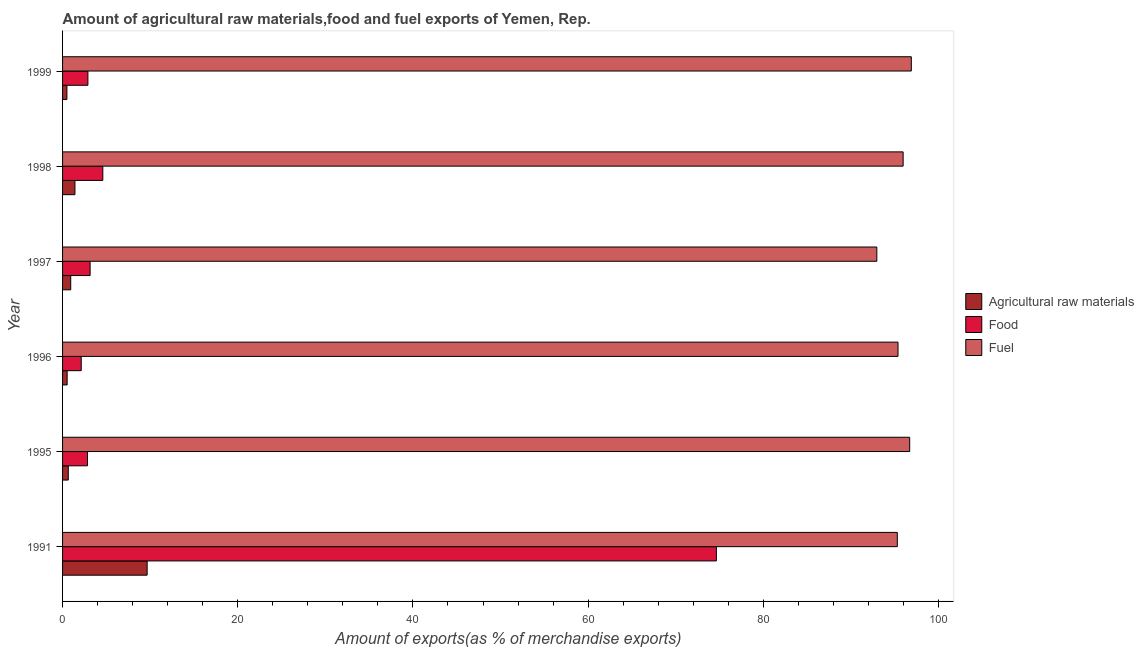How many different coloured bars are there?
Make the answer very short. 3. Are the number of bars per tick equal to the number of legend labels?
Your answer should be very brief. Yes. Are the number of bars on each tick of the Y-axis equal?
Make the answer very short. Yes. What is the percentage of fuel exports in 1991?
Make the answer very short. 95.3. Across all years, what is the maximum percentage of fuel exports?
Give a very brief answer. 96.9. Across all years, what is the minimum percentage of fuel exports?
Your answer should be very brief. 92.96. In which year was the percentage of food exports minimum?
Keep it short and to the point. 1996. What is the total percentage of raw materials exports in the graph?
Your answer should be compact. 13.67. What is the difference between the percentage of raw materials exports in 1998 and that in 1999?
Give a very brief answer. 0.92. What is the difference between the percentage of food exports in 1995 and the percentage of fuel exports in 1996?
Offer a very short reply. -92.53. What is the average percentage of fuel exports per year?
Offer a very short reply. 95.54. In the year 1995, what is the difference between the percentage of food exports and percentage of raw materials exports?
Your response must be concise. 2.19. What is the ratio of the percentage of fuel exports in 1991 to that in 1999?
Offer a very short reply. 0.98. Is the percentage of fuel exports in 1991 less than that in 1995?
Offer a terse response. Yes. Is the difference between the percentage of fuel exports in 1996 and 1998 greater than the difference between the percentage of raw materials exports in 1996 and 1998?
Offer a very short reply. Yes. What is the difference between the highest and the second highest percentage of raw materials exports?
Keep it short and to the point. 8.24. What is the difference between the highest and the lowest percentage of fuel exports?
Offer a terse response. 3.94. In how many years, is the percentage of food exports greater than the average percentage of food exports taken over all years?
Provide a short and direct response. 1. Is the sum of the percentage of food exports in 1991 and 1995 greater than the maximum percentage of raw materials exports across all years?
Offer a very short reply. Yes. What does the 1st bar from the top in 1995 represents?
Give a very brief answer. Fuel. What does the 1st bar from the bottom in 1998 represents?
Your answer should be compact. Agricultural raw materials. Are all the bars in the graph horizontal?
Provide a succinct answer. Yes. What is the difference between two consecutive major ticks on the X-axis?
Ensure brevity in your answer.  20. Are the values on the major ticks of X-axis written in scientific E-notation?
Your answer should be compact. No. Does the graph contain any zero values?
Give a very brief answer. No. Does the graph contain grids?
Your answer should be compact. No. Where does the legend appear in the graph?
Ensure brevity in your answer.  Center right. How are the legend labels stacked?
Make the answer very short. Vertical. What is the title of the graph?
Offer a very short reply. Amount of agricultural raw materials,food and fuel exports of Yemen, Rep. Does "Transport equipments" appear as one of the legend labels in the graph?
Offer a terse response. No. What is the label or title of the X-axis?
Offer a terse response. Amount of exports(as % of merchandise exports). What is the label or title of the Y-axis?
Your answer should be very brief. Year. What is the Amount of exports(as % of merchandise exports) in Agricultural raw materials in 1991?
Provide a succinct answer. 9.65. What is the Amount of exports(as % of merchandise exports) in Food in 1991?
Offer a very short reply. 74.64. What is the Amount of exports(as % of merchandise exports) in Fuel in 1991?
Provide a succinct answer. 95.3. What is the Amount of exports(as % of merchandise exports) of Agricultural raw materials in 1995?
Your response must be concise. 0.65. What is the Amount of exports(as % of merchandise exports) of Food in 1995?
Provide a short and direct response. 2.85. What is the Amount of exports(as % of merchandise exports) in Fuel in 1995?
Provide a succinct answer. 96.71. What is the Amount of exports(as % of merchandise exports) in Agricultural raw materials in 1996?
Your response must be concise. 0.52. What is the Amount of exports(as % of merchandise exports) in Food in 1996?
Offer a very short reply. 2.13. What is the Amount of exports(as % of merchandise exports) of Fuel in 1996?
Offer a terse response. 95.38. What is the Amount of exports(as % of merchandise exports) in Agricultural raw materials in 1997?
Give a very brief answer. 0.93. What is the Amount of exports(as % of merchandise exports) of Food in 1997?
Ensure brevity in your answer.  3.14. What is the Amount of exports(as % of merchandise exports) in Fuel in 1997?
Your answer should be compact. 92.96. What is the Amount of exports(as % of merchandise exports) of Agricultural raw materials in 1998?
Offer a very short reply. 1.41. What is the Amount of exports(as % of merchandise exports) in Food in 1998?
Make the answer very short. 4.59. What is the Amount of exports(as % of merchandise exports) of Fuel in 1998?
Offer a terse response. 95.96. What is the Amount of exports(as % of merchandise exports) in Agricultural raw materials in 1999?
Your response must be concise. 0.5. What is the Amount of exports(as % of merchandise exports) in Food in 1999?
Your answer should be very brief. 2.89. What is the Amount of exports(as % of merchandise exports) of Fuel in 1999?
Give a very brief answer. 96.9. Across all years, what is the maximum Amount of exports(as % of merchandise exports) in Agricultural raw materials?
Keep it short and to the point. 9.65. Across all years, what is the maximum Amount of exports(as % of merchandise exports) in Food?
Offer a terse response. 74.64. Across all years, what is the maximum Amount of exports(as % of merchandise exports) of Fuel?
Your response must be concise. 96.9. Across all years, what is the minimum Amount of exports(as % of merchandise exports) of Agricultural raw materials?
Provide a succinct answer. 0.5. Across all years, what is the minimum Amount of exports(as % of merchandise exports) in Food?
Offer a terse response. 2.13. Across all years, what is the minimum Amount of exports(as % of merchandise exports) of Fuel?
Ensure brevity in your answer.  92.96. What is the total Amount of exports(as % of merchandise exports) of Agricultural raw materials in the graph?
Offer a terse response. 13.67. What is the total Amount of exports(as % of merchandise exports) of Food in the graph?
Your response must be concise. 90.25. What is the total Amount of exports(as % of merchandise exports) of Fuel in the graph?
Make the answer very short. 573.21. What is the difference between the Amount of exports(as % of merchandise exports) in Agricultural raw materials in 1991 and that in 1995?
Offer a terse response. 9. What is the difference between the Amount of exports(as % of merchandise exports) in Food in 1991 and that in 1995?
Your response must be concise. 71.8. What is the difference between the Amount of exports(as % of merchandise exports) in Fuel in 1991 and that in 1995?
Ensure brevity in your answer.  -1.41. What is the difference between the Amount of exports(as % of merchandise exports) of Agricultural raw materials in 1991 and that in 1996?
Give a very brief answer. 9.13. What is the difference between the Amount of exports(as % of merchandise exports) in Food in 1991 and that in 1996?
Offer a very short reply. 72.51. What is the difference between the Amount of exports(as % of merchandise exports) of Fuel in 1991 and that in 1996?
Provide a succinct answer. -0.08. What is the difference between the Amount of exports(as % of merchandise exports) in Agricultural raw materials in 1991 and that in 1997?
Offer a terse response. 8.72. What is the difference between the Amount of exports(as % of merchandise exports) in Food in 1991 and that in 1997?
Provide a short and direct response. 71.5. What is the difference between the Amount of exports(as % of merchandise exports) in Fuel in 1991 and that in 1997?
Give a very brief answer. 2.34. What is the difference between the Amount of exports(as % of merchandise exports) in Agricultural raw materials in 1991 and that in 1998?
Your answer should be very brief. 8.24. What is the difference between the Amount of exports(as % of merchandise exports) of Food in 1991 and that in 1998?
Offer a very short reply. 70.05. What is the difference between the Amount of exports(as % of merchandise exports) in Fuel in 1991 and that in 1998?
Offer a terse response. -0.66. What is the difference between the Amount of exports(as % of merchandise exports) of Agricultural raw materials in 1991 and that in 1999?
Your answer should be very brief. 9.16. What is the difference between the Amount of exports(as % of merchandise exports) of Food in 1991 and that in 1999?
Your answer should be compact. 71.75. What is the difference between the Amount of exports(as % of merchandise exports) in Fuel in 1991 and that in 1999?
Ensure brevity in your answer.  -1.6. What is the difference between the Amount of exports(as % of merchandise exports) of Agricultural raw materials in 1995 and that in 1996?
Offer a terse response. 0.13. What is the difference between the Amount of exports(as % of merchandise exports) of Food in 1995 and that in 1996?
Provide a succinct answer. 0.72. What is the difference between the Amount of exports(as % of merchandise exports) in Fuel in 1995 and that in 1996?
Your response must be concise. 1.33. What is the difference between the Amount of exports(as % of merchandise exports) in Agricultural raw materials in 1995 and that in 1997?
Your answer should be very brief. -0.28. What is the difference between the Amount of exports(as % of merchandise exports) in Food in 1995 and that in 1997?
Give a very brief answer. -0.3. What is the difference between the Amount of exports(as % of merchandise exports) of Fuel in 1995 and that in 1997?
Your answer should be very brief. 3.75. What is the difference between the Amount of exports(as % of merchandise exports) of Agricultural raw materials in 1995 and that in 1998?
Provide a short and direct response. -0.76. What is the difference between the Amount of exports(as % of merchandise exports) of Food in 1995 and that in 1998?
Offer a terse response. -1.75. What is the difference between the Amount of exports(as % of merchandise exports) of Fuel in 1995 and that in 1998?
Your response must be concise. 0.75. What is the difference between the Amount of exports(as % of merchandise exports) in Agricultural raw materials in 1995 and that in 1999?
Ensure brevity in your answer.  0.16. What is the difference between the Amount of exports(as % of merchandise exports) in Food in 1995 and that in 1999?
Offer a very short reply. -0.05. What is the difference between the Amount of exports(as % of merchandise exports) in Fuel in 1995 and that in 1999?
Provide a succinct answer. -0.19. What is the difference between the Amount of exports(as % of merchandise exports) in Agricultural raw materials in 1996 and that in 1997?
Offer a terse response. -0.41. What is the difference between the Amount of exports(as % of merchandise exports) of Food in 1996 and that in 1997?
Make the answer very short. -1.01. What is the difference between the Amount of exports(as % of merchandise exports) in Fuel in 1996 and that in 1997?
Your response must be concise. 2.42. What is the difference between the Amount of exports(as % of merchandise exports) in Agricultural raw materials in 1996 and that in 1998?
Make the answer very short. -0.89. What is the difference between the Amount of exports(as % of merchandise exports) in Food in 1996 and that in 1998?
Your answer should be very brief. -2.46. What is the difference between the Amount of exports(as % of merchandise exports) of Fuel in 1996 and that in 1998?
Offer a very short reply. -0.58. What is the difference between the Amount of exports(as % of merchandise exports) in Agricultural raw materials in 1996 and that in 1999?
Provide a short and direct response. 0.03. What is the difference between the Amount of exports(as % of merchandise exports) of Food in 1996 and that in 1999?
Provide a succinct answer. -0.76. What is the difference between the Amount of exports(as % of merchandise exports) of Fuel in 1996 and that in 1999?
Keep it short and to the point. -1.52. What is the difference between the Amount of exports(as % of merchandise exports) in Agricultural raw materials in 1997 and that in 1998?
Provide a succinct answer. -0.48. What is the difference between the Amount of exports(as % of merchandise exports) in Food in 1997 and that in 1998?
Keep it short and to the point. -1.45. What is the difference between the Amount of exports(as % of merchandise exports) of Fuel in 1997 and that in 1998?
Give a very brief answer. -3. What is the difference between the Amount of exports(as % of merchandise exports) of Agricultural raw materials in 1997 and that in 1999?
Offer a terse response. 0.44. What is the difference between the Amount of exports(as % of merchandise exports) in Food in 1997 and that in 1999?
Keep it short and to the point. 0.25. What is the difference between the Amount of exports(as % of merchandise exports) in Fuel in 1997 and that in 1999?
Offer a terse response. -3.94. What is the difference between the Amount of exports(as % of merchandise exports) in Agricultural raw materials in 1998 and that in 1999?
Keep it short and to the point. 0.92. What is the difference between the Amount of exports(as % of merchandise exports) of Food in 1998 and that in 1999?
Give a very brief answer. 1.7. What is the difference between the Amount of exports(as % of merchandise exports) in Fuel in 1998 and that in 1999?
Make the answer very short. -0.93. What is the difference between the Amount of exports(as % of merchandise exports) of Agricultural raw materials in 1991 and the Amount of exports(as % of merchandise exports) of Food in 1995?
Your answer should be very brief. 6.81. What is the difference between the Amount of exports(as % of merchandise exports) in Agricultural raw materials in 1991 and the Amount of exports(as % of merchandise exports) in Fuel in 1995?
Provide a succinct answer. -87.06. What is the difference between the Amount of exports(as % of merchandise exports) in Food in 1991 and the Amount of exports(as % of merchandise exports) in Fuel in 1995?
Your answer should be compact. -22.07. What is the difference between the Amount of exports(as % of merchandise exports) in Agricultural raw materials in 1991 and the Amount of exports(as % of merchandise exports) in Food in 1996?
Ensure brevity in your answer.  7.52. What is the difference between the Amount of exports(as % of merchandise exports) of Agricultural raw materials in 1991 and the Amount of exports(as % of merchandise exports) of Fuel in 1996?
Provide a succinct answer. -85.72. What is the difference between the Amount of exports(as % of merchandise exports) of Food in 1991 and the Amount of exports(as % of merchandise exports) of Fuel in 1996?
Your answer should be compact. -20.74. What is the difference between the Amount of exports(as % of merchandise exports) of Agricultural raw materials in 1991 and the Amount of exports(as % of merchandise exports) of Food in 1997?
Your answer should be very brief. 6.51. What is the difference between the Amount of exports(as % of merchandise exports) in Agricultural raw materials in 1991 and the Amount of exports(as % of merchandise exports) in Fuel in 1997?
Offer a very short reply. -83.3. What is the difference between the Amount of exports(as % of merchandise exports) of Food in 1991 and the Amount of exports(as % of merchandise exports) of Fuel in 1997?
Provide a succinct answer. -18.32. What is the difference between the Amount of exports(as % of merchandise exports) in Agricultural raw materials in 1991 and the Amount of exports(as % of merchandise exports) in Food in 1998?
Your response must be concise. 5.06. What is the difference between the Amount of exports(as % of merchandise exports) in Agricultural raw materials in 1991 and the Amount of exports(as % of merchandise exports) in Fuel in 1998?
Ensure brevity in your answer.  -86.31. What is the difference between the Amount of exports(as % of merchandise exports) in Food in 1991 and the Amount of exports(as % of merchandise exports) in Fuel in 1998?
Provide a succinct answer. -21.32. What is the difference between the Amount of exports(as % of merchandise exports) of Agricultural raw materials in 1991 and the Amount of exports(as % of merchandise exports) of Food in 1999?
Give a very brief answer. 6.76. What is the difference between the Amount of exports(as % of merchandise exports) of Agricultural raw materials in 1991 and the Amount of exports(as % of merchandise exports) of Fuel in 1999?
Offer a terse response. -87.24. What is the difference between the Amount of exports(as % of merchandise exports) in Food in 1991 and the Amount of exports(as % of merchandise exports) in Fuel in 1999?
Offer a very short reply. -22.25. What is the difference between the Amount of exports(as % of merchandise exports) in Agricultural raw materials in 1995 and the Amount of exports(as % of merchandise exports) in Food in 1996?
Your answer should be compact. -1.48. What is the difference between the Amount of exports(as % of merchandise exports) of Agricultural raw materials in 1995 and the Amount of exports(as % of merchandise exports) of Fuel in 1996?
Give a very brief answer. -94.73. What is the difference between the Amount of exports(as % of merchandise exports) of Food in 1995 and the Amount of exports(as % of merchandise exports) of Fuel in 1996?
Make the answer very short. -92.53. What is the difference between the Amount of exports(as % of merchandise exports) of Agricultural raw materials in 1995 and the Amount of exports(as % of merchandise exports) of Food in 1997?
Make the answer very short. -2.49. What is the difference between the Amount of exports(as % of merchandise exports) in Agricultural raw materials in 1995 and the Amount of exports(as % of merchandise exports) in Fuel in 1997?
Keep it short and to the point. -92.31. What is the difference between the Amount of exports(as % of merchandise exports) of Food in 1995 and the Amount of exports(as % of merchandise exports) of Fuel in 1997?
Your answer should be compact. -90.11. What is the difference between the Amount of exports(as % of merchandise exports) in Agricultural raw materials in 1995 and the Amount of exports(as % of merchandise exports) in Food in 1998?
Your answer should be compact. -3.94. What is the difference between the Amount of exports(as % of merchandise exports) of Agricultural raw materials in 1995 and the Amount of exports(as % of merchandise exports) of Fuel in 1998?
Your answer should be compact. -95.31. What is the difference between the Amount of exports(as % of merchandise exports) in Food in 1995 and the Amount of exports(as % of merchandise exports) in Fuel in 1998?
Offer a terse response. -93.12. What is the difference between the Amount of exports(as % of merchandise exports) of Agricultural raw materials in 1995 and the Amount of exports(as % of merchandise exports) of Food in 1999?
Ensure brevity in your answer.  -2.24. What is the difference between the Amount of exports(as % of merchandise exports) in Agricultural raw materials in 1995 and the Amount of exports(as % of merchandise exports) in Fuel in 1999?
Provide a succinct answer. -96.25. What is the difference between the Amount of exports(as % of merchandise exports) in Food in 1995 and the Amount of exports(as % of merchandise exports) in Fuel in 1999?
Make the answer very short. -94.05. What is the difference between the Amount of exports(as % of merchandise exports) of Agricultural raw materials in 1996 and the Amount of exports(as % of merchandise exports) of Food in 1997?
Keep it short and to the point. -2.62. What is the difference between the Amount of exports(as % of merchandise exports) in Agricultural raw materials in 1996 and the Amount of exports(as % of merchandise exports) in Fuel in 1997?
Your answer should be very brief. -92.44. What is the difference between the Amount of exports(as % of merchandise exports) of Food in 1996 and the Amount of exports(as % of merchandise exports) of Fuel in 1997?
Give a very brief answer. -90.83. What is the difference between the Amount of exports(as % of merchandise exports) in Agricultural raw materials in 1996 and the Amount of exports(as % of merchandise exports) in Food in 1998?
Provide a short and direct response. -4.07. What is the difference between the Amount of exports(as % of merchandise exports) in Agricultural raw materials in 1996 and the Amount of exports(as % of merchandise exports) in Fuel in 1998?
Your answer should be very brief. -95.44. What is the difference between the Amount of exports(as % of merchandise exports) of Food in 1996 and the Amount of exports(as % of merchandise exports) of Fuel in 1998?
Give a very brief answer. -93.83. What is the difference between the Amount of exports(as % of merchandise exports) in Agricultural raw materials in 1996 and the Amount of exports(as % of merchandise exports) in Food in 1999?
Provide a succinct answer. -2.37. What is the difference between the Amount of exports(as % of merchandise exports) of Agricultural raw materials in 1996 and the Amount of exports(as % of merchandise exports) of Fuel in 1999?
Provide a short and direct response. -96.38. What is the difference between the Amount of exports(as % of merchandise exports) in Food in 1996 and the Amount of exports(as % of merchandise exports) in Fuel in 1999?
Your answer should be very brief. -94.77. What is the difference between the Amount of exports(as % of merchandise exports) in Agricultural raw materials in 1997 and the Amount of exports(as % of merchandise exports) in Food in 1998?
Provide a succinct answer. -3.66. What is the difference between the Amount of exports(as % of merchandise exports) in Agricultural raw materials in 1997 and the Amount of exports(as % of merchandise exports) in Fuel in 1998?
Keep it short and to the point. -95.03. What is the difference between the Amount of exports(as % of merchandise exports) of Food in 1997 and the Amount of exports(as % of merchandise exports) of Fuel in 1998?
Your response must be concise. -92.82. What is the difference between the Amount of exports(as % of merchandise exports) of Agricultural raw materials in 1997 and the Amount of exports(as % of merchandise exports) of Food in 1999?
Provide a succinct answer. -1.96. What is the difference between the Amount of exports(as % of merchandise exports) in Agricultural raw materials in 1997 and the Amount of exports(as % of merchandise exports) in Fuel in 1999?
Make the answer very short. -95.97. What is the difference between the Amount of exports(as % of merchandise exports) in Food in 1997 and the Amount of exports(as % of merchandise exports) in Fuel in 1999?
Offer a very short reply. -93.75. What is the difference between the Amount of exports(as % of merchandise exports) in Agricultural raw materials in 1998 and the Amount of exports(as % of merchandise exports) in Food in 1999?
Make the answer very short. -1.48. What is the difference between the Amount of exports(as % of merchandise exports) of Agricultural raw materials in 1998 and the Amount of exports(as % of merchandise exports) of Fuel in 1999?
Give a very brief answer. -95.49. What is the difference between the Amount of exports(as % of merchandise exports) in Food in 1998 and the Amount of exports(as % of merchandise exports) in Fuel in 1999?
Your answer should be compact. -92.3. What is the average Amount of exports(as % of merchandise exports) of Agricultural raw materials per year?
Your answer should be very brief. 2.28. What is the average Amount of exports(as % of merchandise exports) of Food per year?
Offer a very short reply. 15.04. What is the average Amount of exports(as % of merchandise exports) of Fuel per year?
Offer a terse response. 95.54. In the year 1991, what is the difference between the Amount of exports(as % of merchandise exports) of Agricultural raw materials and Amount of exports(as % of merchandise exports) of Food?
Ensure brevity in your answer.  -64.99. In the year 1991, what is the difference between the Amount of exports(as % of merchandise exports) in Agricultural raw materials and Amount of exports(as % of merchandise exports) in Fuel?
Provide a succinct answer. -85.65. In the year 1991, what is the difference between the Amount of exports(as % of merchandise exports) in Food and Amount of exports(as % of merchandise exports) in Fuel?
Keep it short and to the point. -20.66. In the year 1995, what is the difference between the Amount of exports(as % of merchandise exports) in Agricultural raw materials and Amount of exports(as % of merchandise exports) in Food?
Give a very brief answer. -2.19. In the year 1995, what is the difference between the Amount of exports(as % of merchandise exports) in Agricultural raw materials and Amount of exports(as % of merchandise exports) in Fuel?
Your answer should be compact. -96.06. In the year 1995, what is the difference between the Amount of exports(as % of merchandise exports) in Food and Amount of exports(as % of merchandise exports) in Fuel?
Ensure brevity in your answer.  -93.87. In the year 1996, what is the difference between the Amount of exports(as % of merchandise exports) of Agricultural raw materials and Amount of exports(as % of merchandise exports) of Food?
Offer a terse response. -1.61. In the year 1996, what is the difference between the Amount of exports(as % of merchandise exports) of Agricultural raw materials and Amount of exports(as % of merchandise exports) of Fuel?
Keep it short and to the point. -94.86. In the year 1996, what is the difference between the Amount of exports(as % of merchandise exports) of Food and Amount of exports(as % of merchandise exports) of Fuel?
Provide a succinct answer. -93.25. In the year 1997, what is the difference between the Amount of exports(as % of merchandise exports) of Agricultural raw materials and Amount of exports(as % of merchandise exports) of Food?
Offer a terse response. -2.21. In the year 1997, what is the difference between the Amount of exports(as % of merchandise exports) in Agricultural raw materials and Amount of exports(as % of merchandise exports) in Fuel?
Offer a terse response. -92.03. In the year 1997, what is the difference between the Amount of exports(as % of merchandise exports) of Food and Amount of exports(as % of merchandise exports) of Fuel?
Provide a short and direct response. -89.82. In the year 1998, what is the difference between the Amount of exports(as % of merchandise exports) in Agricultural raw materials and Amount of exports(as % of merchandise exports) in Food?
Offer a very short reply. -3.18. In the year 1998, what is the difference between the Amount of exports(as % of merchandise exports) in Agricultural raw materials and Amount of exports(as % of merchandise exports) in Fuel?
Ensure brevity in your answer.  -94.55. In the year 1998, what is the difference between the Amount of exports(as % of merchandise exports) in Food and Amount of exports(as % of merchandise exports) in Fuel?
Offer a very short reply. -91.37. In the year 1999, what is the difference between the Amount of exports(as % of merchandise exports) in Agricultural raw materials and Amount of exports(as % of merchandise exports) in Food?
Provide a succinct answer. -2.4. In the year 1999, what is the difference between the Amount of exports(as % of merchandise exports) in Agricultural raw materials and Amount of exports(as % of merchandise exports) in Fuel?
Offer a terse response. -96.4. In the year 1999, what is the difference between the Amount of exports(as % of merchandise exports) in Food and Amount of exports(as % of merchandise exports) in Fuel?
Provide a succinct answer. -94.01. What is the ratio of the Amount of exports(as % of merchandise exports) of Agricultural raw materials in 1991 to that in 1995?
Offer a terse response. 14.8. What is the ratio of the Amount of exports(as % of merchandise exports) of Food in 1991 to that in 1995?
Ensure brevity in your answer.  26.23. What is the ratio of the Amount of exports(as % of merchandise exports) in Fuel in 1991 to that in 1995?
Your answer should be compact. 0.99. What is the ratio of the Amount of exports(as % of merchandise exports) of Agricultural raw materials in 1991 to that in 1996?
Provide a short and direct response. 18.47. What is the ratio of the Amount of exports(as % of merchandise exports) in Food in 1991 to that in 1996?
Give a very brief answer. 35.05. What is the ratio of the Amount of exports(as % of merchandise exports) of Fuel in 1991 to that in 1996?
Offer a terse response. 1. What is the ratio of the Amount of exports(as % of merchandise exports) of Agricultural raw materials in 1991 to that in 1997?
Offer a very short reply. 10.37. What is the ratio of the Amount of exports(as % of merchandise exports) in Food in 1991 to that in 1997?
Provide a succinct answer. 23.74. What is the ratio of the Amount of exports(as % of merchandise exports) in Fuel in 1991 to that in 1997?
Ensure brevity in your answer.  1.03. What is the ratio of the Amount of exports(as % of merchandise exports) in Agricultural raw materials in 1991 to that in 1998?
Your answer should be compact. 6.84. What is the ratio of the Amount of exports(as % of merchandise exports) in Food in 1991 to that in 1998?
Keep it short and to the point. 16.25. What is the ratio of the Amount of exports(as % of merchandise exports) in Fuel in 1991 to that in 1998?
Offer a terse response. 0.99. What is the ratio of the Amount of exports(as % of merchandise exports) of Agricultural raw materials in 1991 to that in 1999?
Your response must be concise. 19.46. What is the ratio of the Amount of exports(as % of merchandise exports) in Food in 1991 to that in 1999?
Keep it short and to the point. 25.81. What is the ratio of the Amount of exports(as % of merchandise exports) of Fuel in 1991 to that in 1999?
Your answer should be compact. 0.98. What is the ratio of the Amount of exports(as % of merchandise exports) of Agricultural raw materials in 1995 to that in 1996?
Make the answer very short. 1.25. What is the ratio of the Amount of exports(as % of merchandise exports) of Food in 1995 to that in 1996?
Offer a terse response. 1.34. What is the ratio of the Amount of exports(as % of merchandise exports) of Fuel in 1995 to that in 1996?
Your response must be concise. 1.01. What is the ratio of the Amount of exports(as % of merchandise exports) of Agricultural raw materials in 1995 to that in 1997?
Offer a very short reply. 0.7. What is the ratio of the Amount of exports(as % of merchandise exports) in Food in 1995 to that in 1997?
Your answer should be very brief. 0.91. What is the ratio of the Amount of exports(as % of merchandise exports) in Fuel in 1995 to that in 1997?
Your answer should be compact. 1.04. What is the ratio of the Amount of exports(as % of merchandise exports) of Agricultural raw materials in 1995 to that in 1998?
Offer a terse response. 0.46. What is the ratio of the Amount of exports(as % of merchandise exports) of Food in 1995 to that in 1998?
Keep it short and to the point. 0.62. What is the ratio of the Amount of exports(as % of merchandise exports) of Agricultural raw materials in 1995 to that in 1999?
Make the answer very short. 1.31. What is the ratio of the Amount of exports(as % of merchandise exports) in Food in 1995 to that in 1999?
Give a very brief answer. 0.98. What is the ratio of the Amount of exports(as % of merchandise exports) of Agricultural raw materials in 1996 to that in 1997?
Your answer should be compact. 0.56. What is the ratio of the Amount of exports(as % of merchandise exports) of Food in 1996 to that in 1997?
Make the answer very short. 0.68. What is the ratio of the Amount of exports(as % of merchandise exports) in Fuel in 1996 to that in 1997?
Ensure brevity in your answer.  1.03. What is the ratio of the Amount of exports(as % of merchandise exports) in Agricultural raw materials in 1996 to that in 1998?
Your answer should be very brief. 0.37. What is the ratio of the Amount of exports(as % of merchandise exports) in Food in 1996 to that in 1998?
Offer a very short reply. 0.46. What is the ratio of the Amount of exports(as % of merchandise exports) in Fuel in 1996 to that in 1998?
Your answer should be very brief. 0.99. What is the ratio of the Amount of exports(as % of merchandise exports) of Agricultural raw materials in 1996 to that in 1999?
Your answer should be very brief. 1.05. What is the ratio of the Amount of exports(as % of merchandise exports) in Food in 1996 to that in 1999?
Provide a succinct answer. 0.74. What is the ratio of the Amount of exports(as % of merchandise exports) in Fuel in 1996 to that in 1999?
Offer a very short reply. 0.98. What is the ratio of the Amount of exports(as % of merchandise exports) in Agricultural raw materials in 1997 to that in 1998?
Offer a terse response. 0.66. What is the ratio of the Amount of exports(as % of merchandise exports) of Food in 1997 to that in 1998?
Make the answer very short. 0.68. What is the ratio of the Amount of exports(as % of merchandise exports) in Fuel in 1997 to that in 1998?
Your answer should be compact. 0.97. What is the ratio of the Amount of exports(as % of merchandise exports) in Agricultural raw materials in 1997 to that in 1999?
Provide a succinct answer. 1.88. What is the ratio of the Amount of exports(as % of merchandise exports) in Food in 1997 to that in 1999?
Your answer should be compact. 1.09. What is the ratio of the Amount of exports(as % of merchandise exports) in Fuel in 1997 to that in 1999?
Offer a very short reply. 0.96. What is the ratio of the Amount of exports(as % of merchandise exports) in Agricultural raw materials in 1998 to that in 1999?
Provide a succinct answer. 2.85. What is the ratio of the Amount of exports(as % of merchandise exports) in Food in 1998 to that in 1999?
Your answer should be very brief. 1.59. What is the ratio of the Amount of exports(as % of merchandise exports) of Fuel in 1998 to that in 1999?
Ensure brevity in your answer.  0.99. What is the difference between the highest and the second highest Amount of exports(as % of merchandise exports) in Agricultural raw materials?
Provide a short and direct response. 8.24. What is the difference between the highest and the second highest Amount of exports(as % of merchandise exports) of Food?
Your response must be concise. 70.05. What is the difference between the highest and the second highest Amount of exports(as % of merchandise exports) of Fuel?
Keep it short and to the point. 0.19. What is the difference between the highest and the lowest Amount of exports(as % of merchandise exports) in Agricultural raw materials?
Offer a terse response. 9.16. What is the difference between the highest and the lowest Amount of exports(as % of merchandise exports) in Food?
Give a very brief answer. 72.51. What is the difference between the highest and the lowest Amount of exports(as % of merchandise exports) in Fuel?
Keep it short and to the point. 3.94. 